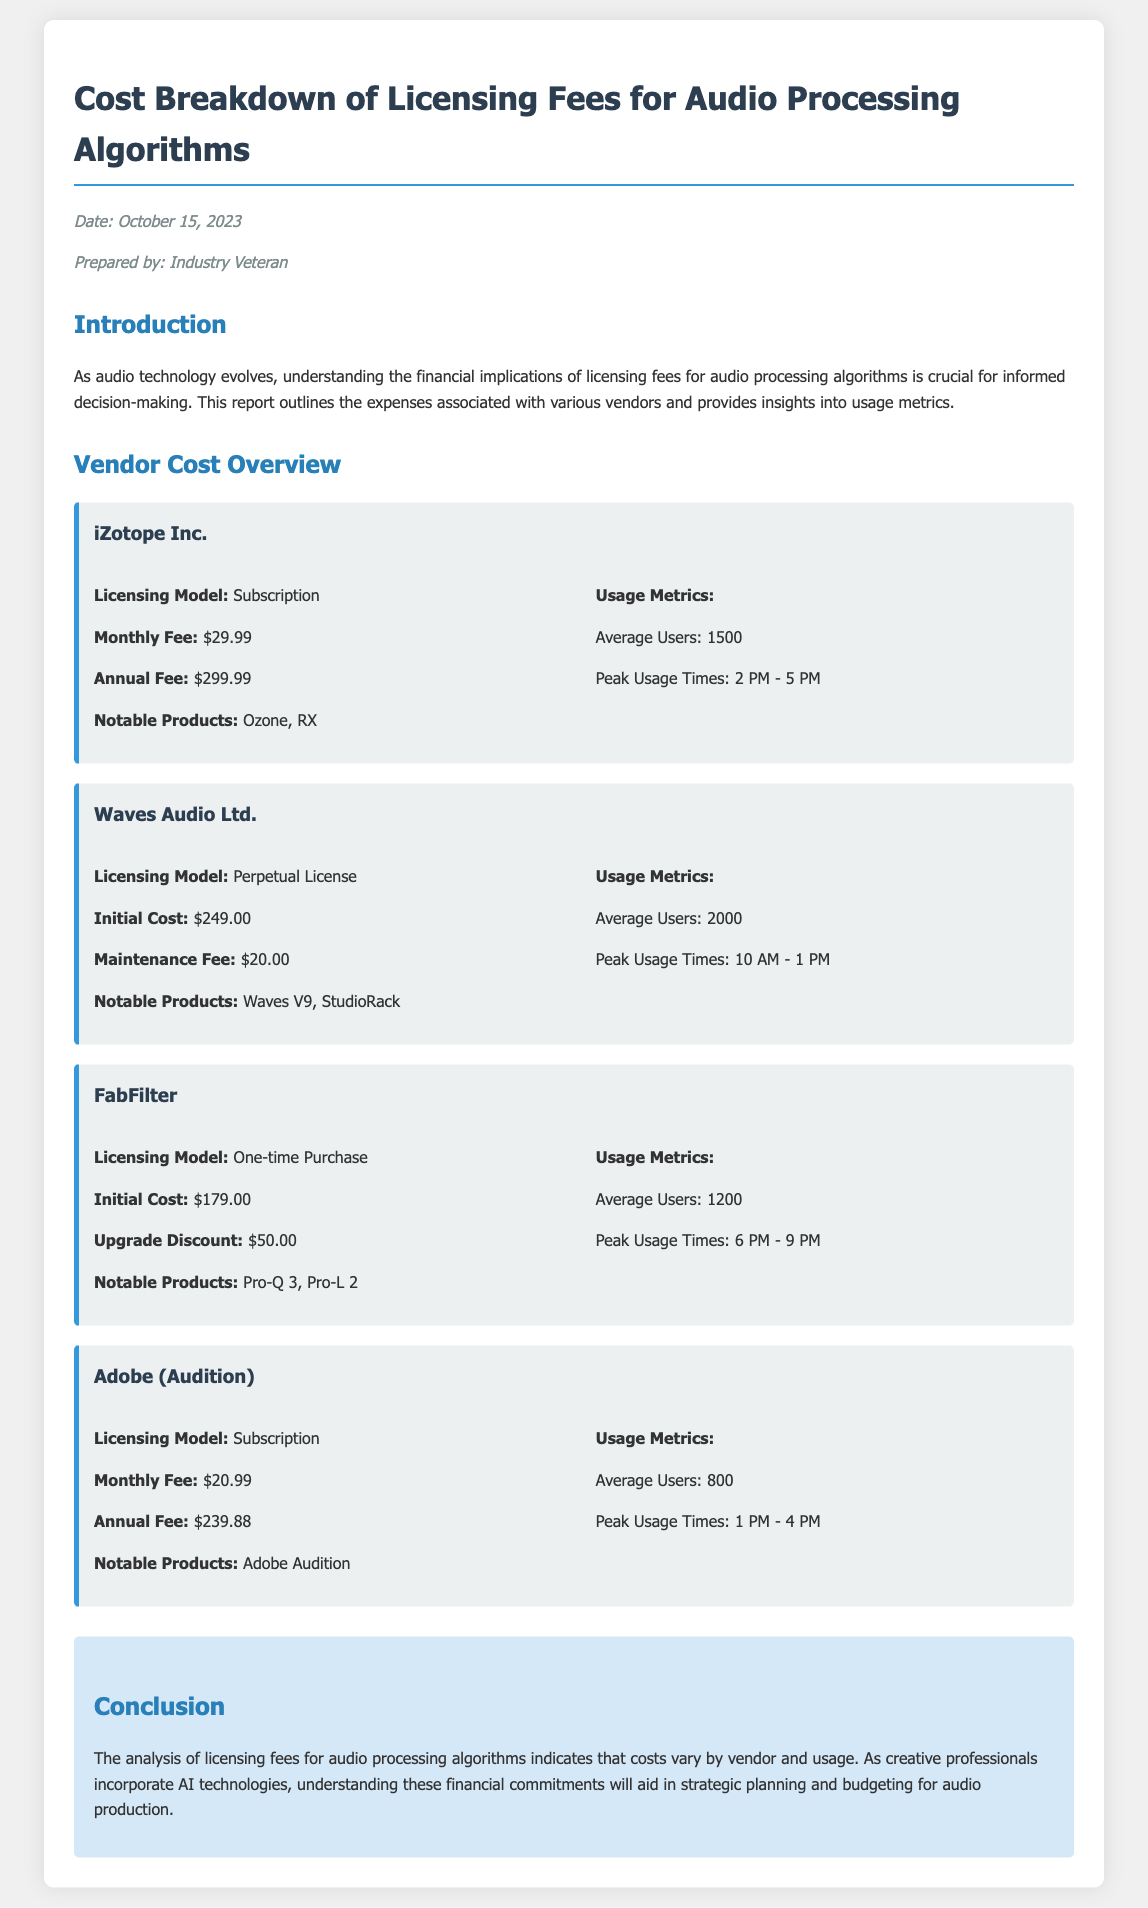What is the date of the report? The date of the report is mentioned in the meta section of the document as October 15, 2023.
Answer: October 15, 2023 Who prepared the report? The report indicates that it was prepared by an "Industry Veteran" as noted in the meta section.
Answer: Industry Veteran What is the monthly fee for iZotope Inc.? The monthly fee for iZotope Inc. is mentioned as $29.99 in the vendor section for iZotope Inc.
Answer: $29.99 What is the average number of users for Waves Audio Ltd.? The document states that the average number of users for Waves Audio Ltd. is 2000 in its usage metrics.
Answer: 2000 Which vendor has a one-time purchase licensing model? The vendor document mentions that FabFilter has a one-time purchase licensing model.
Answer: FabFilter What are the peak usage times for Adobe (Audition)? The peak usage times for Adobe (Audition) are stated as 1 PM - 4 PM in the usage metrics section.
Answer: 1 PM - 4 PM What is the notable product of FabFilter? The notable products of FabFilter are listed as Pro-Q 3 and Pro-L 2 in the vendor details.
Answer: Pro-Q 3, Pro-L 2 Which vendor has the lowest monthly fee? The document indicates that Adobe (Audition) has the lowest monthly fee at $20.99.
Answer: $20.99 What is the total initial cost for Waves Audio Ltd.? The initial cost for Waves Audio Ltd. is stated as $249.00 in the vendor section.
Answer: $249.00 